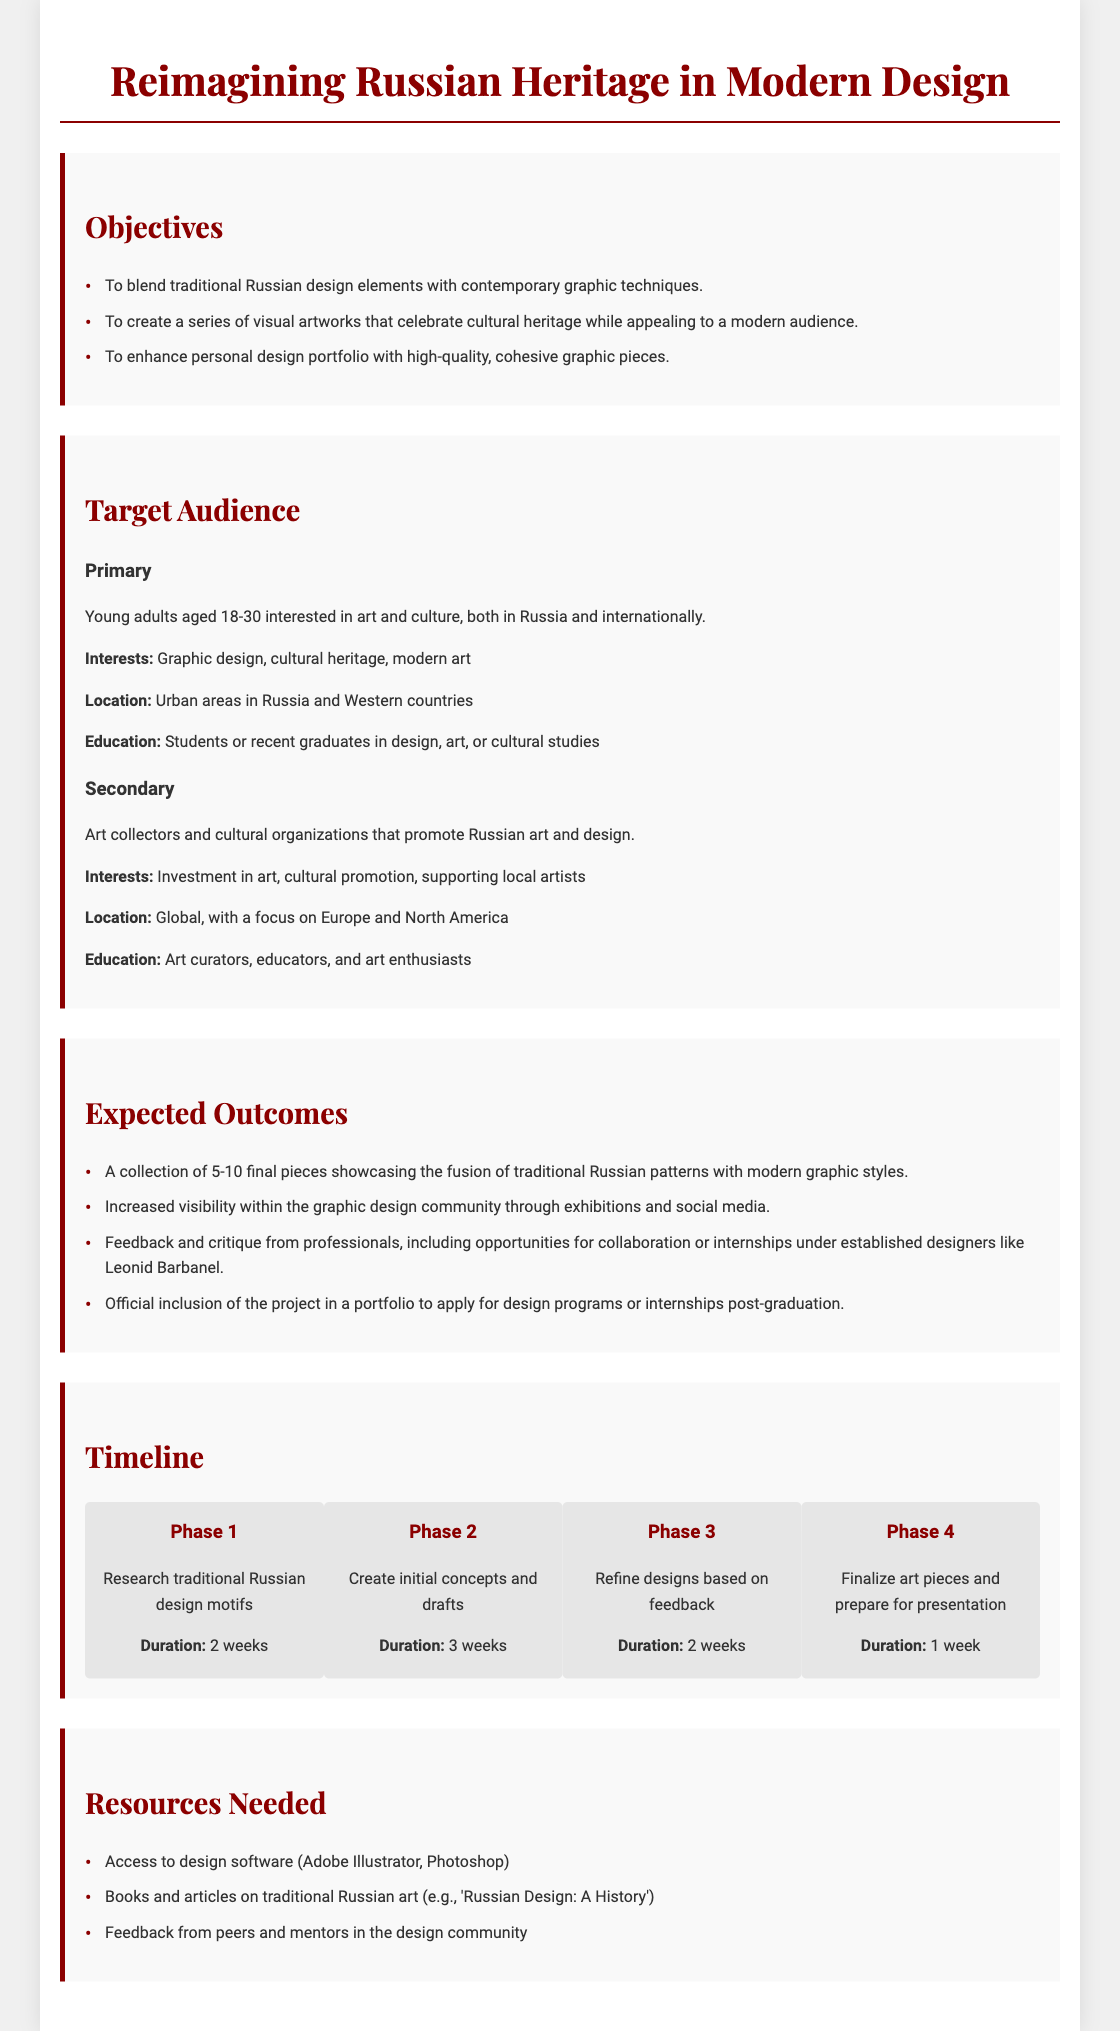What is the main title of the project? The main title is the specific focus of the document and is prominently displayed at the top.
Answer: Reimagining Russian Heritage in Modern Design How many final pieces are expected to be created? The expected outcome statement specifies a range for the final pieces.
Answer: 5-10 What is the duration of Phase 2? The timeline provides the duration for each phase, making it easy to find this information.
Answer: 3 weeks Who is the primary target audience? The section on target audience outlines the group that the project aims to reach primarily.
Answer: Young adults aged 18-30 interested in art and culture What is one resource needed for the project? The resources section lists specific items or supports required for the project.
Answer: Access to design software (Adobe Illustrator, Photoshop) What is one objective of the design project? The objectives section outlines the aims of the project, providing clear statements.
Answer: To blend traditional Russian design elements with contemporary graphic techniques What are the interests of the secondary target audience? The interests of the target audience are mentioned under each category in the target audience section.
Answer: Investment in art, cultural promotion, supporting local artists What phase involves refining designs? The timeline breaks the project into phases, detailing what happens in each one.
Answer: Phase 3 